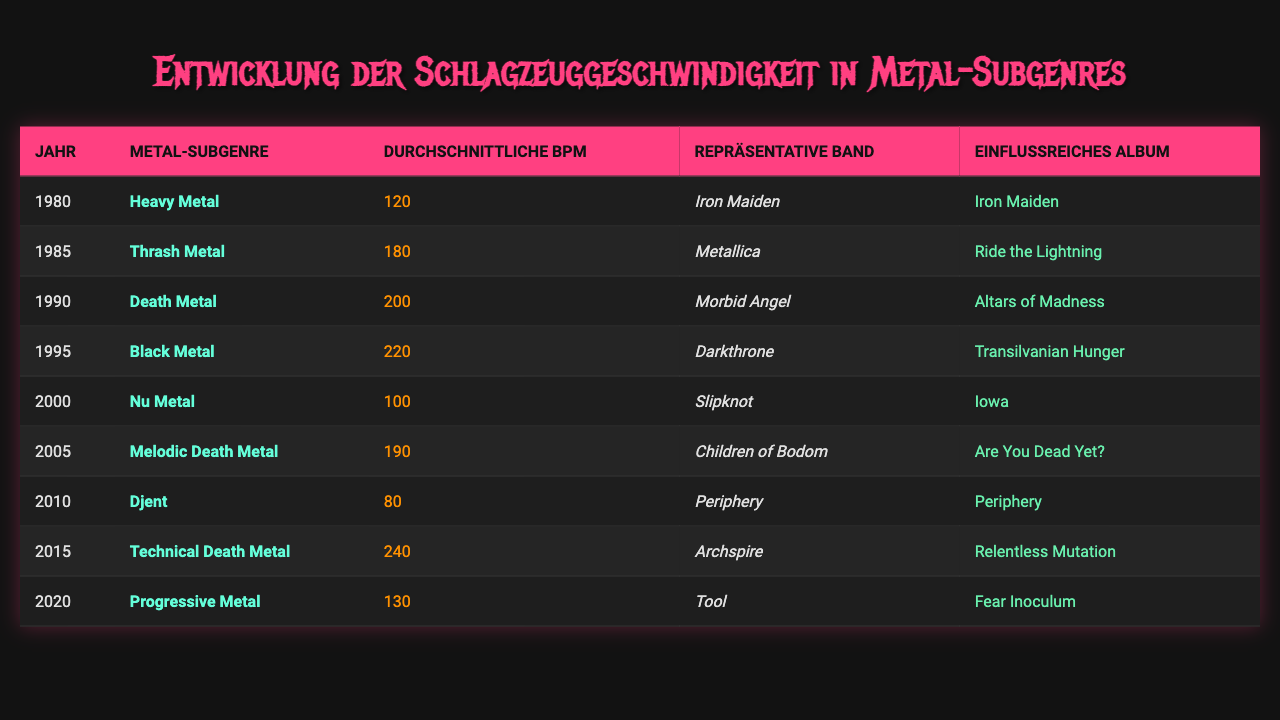What was the average BPM for Black Metal in 1995? The table shows that in 1995, Black Metal had an average BPM of 220.
Answer: 220 Which band is associated with Death Metal from the year 1990? According to the table, the band associated with Death Metal in 1990 is Morbid Angel.
Answer: Morbid Angel What was the average BPM of Nu Metal in the year 2000? The table indicates that Nu Metal had an average BPM of 100 in the year 2000.
Answer: 100 Is it true that Melodic Death Metal had a higher average BPM than Heavy Metal? The average BPM for Melodic Death Metal in 2005 is 190, which is higher than the average BPM of 120 for Heavy Metal in 1980. Therefore, the statement is true.
Answer: Yes How much higher was the average BPM of Technical Death Metal in 2015 compared to the average BPM of Djent in 2010? Technical Death Metal in 2015 had a BPM of 240, while Djent in 2010 had a BPM of 80. The difference is 240 - 80 = 160 BPM, indicating Technical Death Metal was significantly faster.
Answer: 160 BPM Which genre had the highest average BPM over the entire time span? Based on the table, Technical Death Metal in 2015 had the highest average BPM at 240.
Answer: Technical Death Metal What is the average BPM of all the subgenres listed in the table? To find the average BPM, we sum all BPMs: 120 + 180 + 200 + 220 + 100 + 190 + 80 + 240 + 130 = 1,500, and divide by the number of subgenres (9), which gives us an average of 166.67 BPM.
Answer: 166.67 Which representative band is linked to Progressive Metal in 2020? The table states that Tool is the representative band for Progressive Metal in 2020.
Answer: Tool Was there a noticeable increase in BPM from 1990 Death Metal to 1995 Black Metal? The BPM increased from 200 for Death Metal in 1990 to 220 for Black Metal in 1995, indicating an increase of 20 BPM. Thus, there was a noticeable increase.
Answer: Yes What genre had the lowest average BPM in this dataset? The table shows that Djent in 2010 had the lowest average BPM at 80.
Answer: Djent 